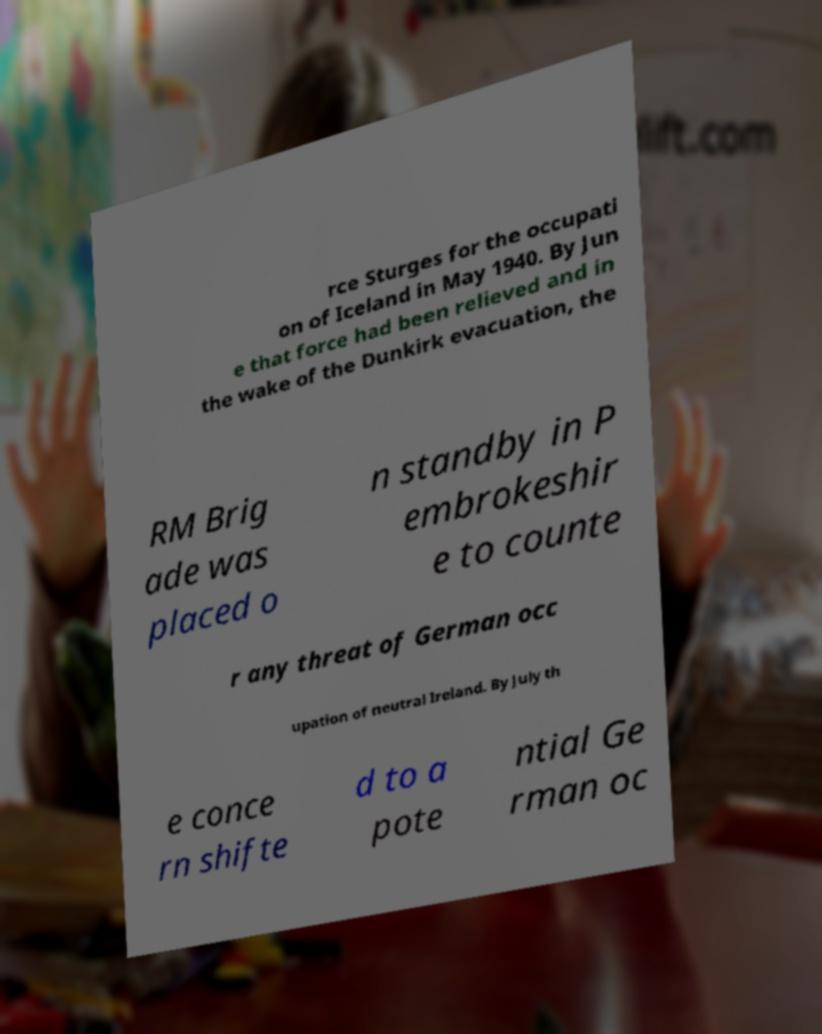Can you accurately transcribe the text from the provided image for me? rce Sturges for the occupati on of Iceland in May 1940. By Jun e that force had been relieved and in the wake of the Dunkirk evacuation, the RM Brig ade was placed o n standby in P embrokeshir e to counte r any threat of German occ upation of neutral Ireland. By July th e conce rn shifte d to a pote ntial Ge rman oc 